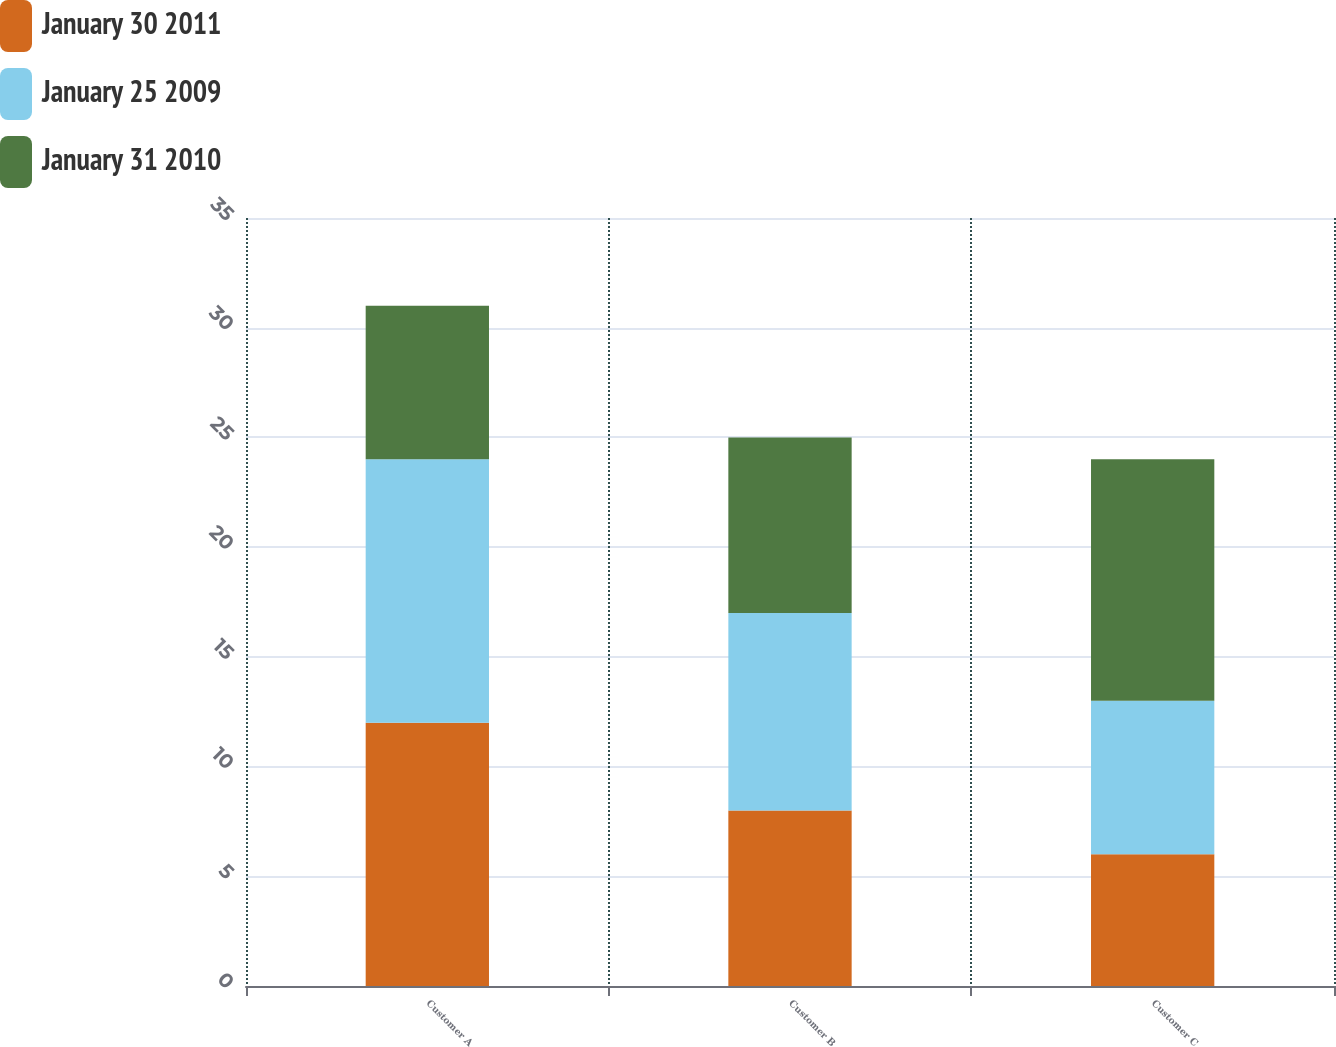<chart> <loc_0><loc_0><loc_500><loc_500><stacked_bar_chart><ecel><fcel>Customer A<fcel>Customer B<fcel>Customer C<nl><fcel>January 30 2011<fcel>12<fcel>8<fcel>6<nl><fcel>January 25 2009<fcel>12<fcel>9<fcel>7<nl><fcel>January 31 2010<fcel>7<fcel>8<fcel>11<nl></chart> 